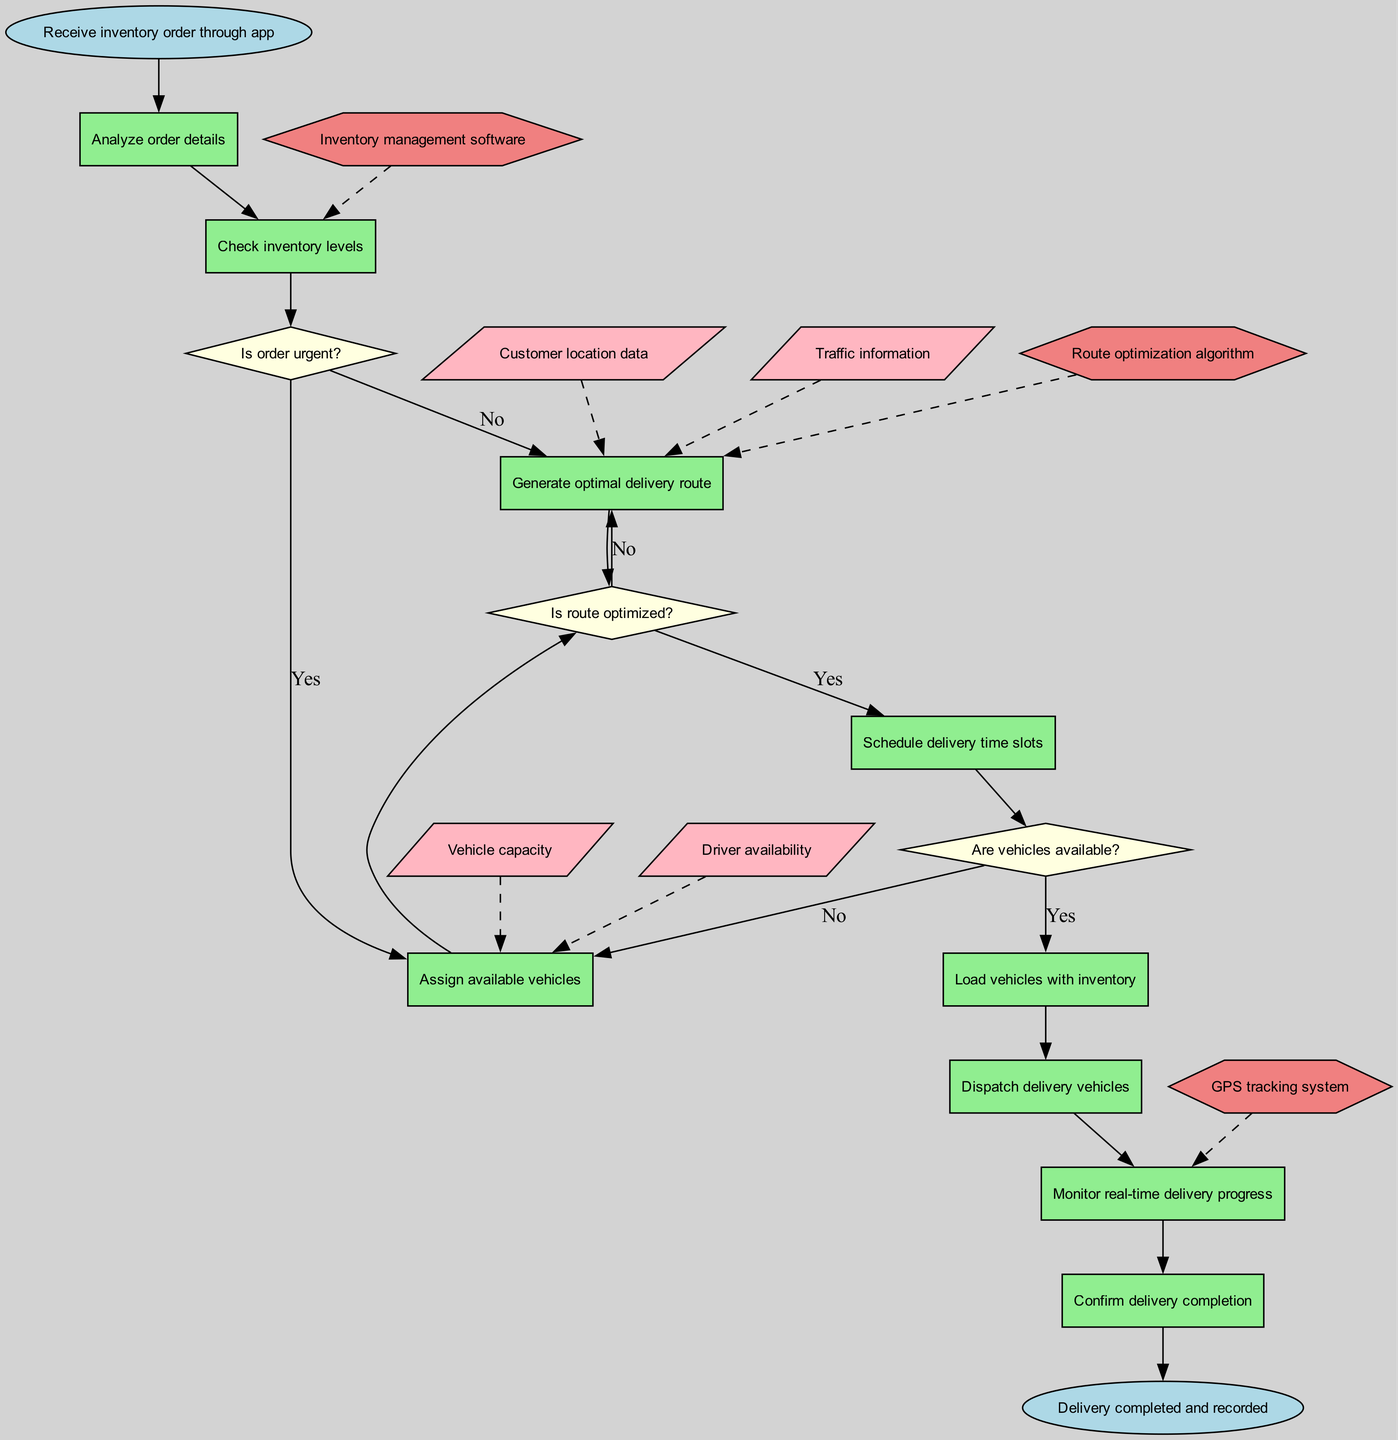What is the starting point of the clinical pathway? The starting point is indicated by the 'start' node, which states "Receive inventory order through app." This node is the first action in the pathway before any decisions or further actions are made.
Answer: Receive inventory order through app How many decision points are in the diagram? The diagram contains three decision points as represented by the diamond-shaped nodes, which are: "Is order urgent?", "Is route optimized?", and "Are vehicles available?". These decision points lead to different actions based on their respective conditions.
Answer: 3 What action occurs immediately after analyzing order details? The action that follows "Analyze order details" is "Check inventory levels," as indicated by the directed edge leading from the analysis step to the inventory check. This shows the sequence of operations in the pathway.
Answer: Check inventory levels If the route is not optimized, which action is taken next? If the route is not optimized (indicated by 'No' on the decision point node "Is route optimized?"), the next action is "Generate optimal delivery route," leading into an action focused on correcting the delivery preparation.
Answer: Generate optimal delivery route What data input is required to generate the optimal delivery route? To generate the optimal delivery route, both "Customer location data" and "Traffic information" are needed, as indicated by dashed edges leading from these data input nodes to the corresponding action node. This suggests a reliance on specific data to accomplish this task.
Answer: Customer location data, Traffic information What happens after dispatching delivery vehicles? After "Dispatch delivery vehicles," the next action in the diagram is "Monitor real-time delivery progress," indicating continuous oversight of the delivery process right after vehicles are sent. This demonstrates the workflow sequence.
Answer: Monitor real-time delivery progress Which systems are integrated as part of the process? The integrated systems are identified in the diagram as three distinct nodes: "GPS tracking system," "Inventory management software," and "Route optimization algorithm." Each of these systems contributes to various actions in the pathway, supporting the overall workflow.
Answer: GPS tracking system, Inventory management software, Route optimization algorithm In what scenario would delivery completion be confirmed? Delivery completion is confirmed as the final action in the pathway following "Monitor real-time delivery progress," indicating all previous steps have been successfully executed, and therefore, the delivery process is complete and documented.
Answer: Delivery completed and recorded 